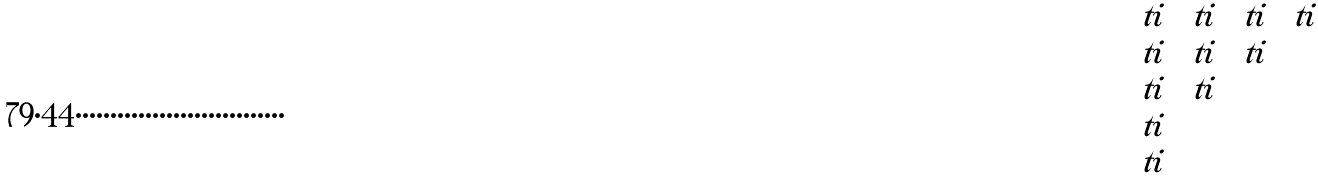Convert formula to latex. <formula><loc_0><loc_0><loc_500><loc_500>\begin{matrix} \ t i & \ t i & \ t i & \ t i \\ \ t i & \ t i & \ t i \\ \ t i & \ t i \\ \ t i \\ \ t i \\ & \end{matrix}</formula> 